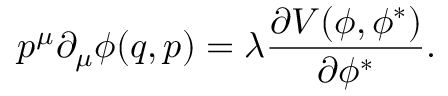<formula> <loc_0><loc_0><loc_500><loc_500>p ^ { \mu } \partial _ { \mu } \phi ( q , p ) = \lambda \frac { \partial V ( \phi , \phi ^ { \ast } ) } { \partial \phi ^ { \ast } } .</formula> 